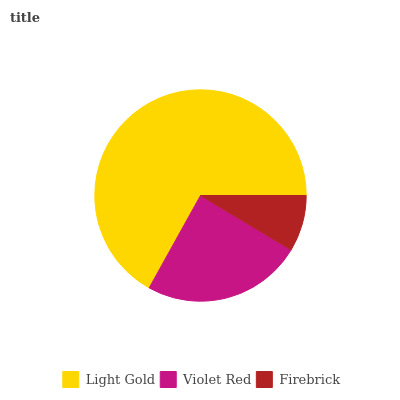Is Firebrick the minimum?
Answer yes or no. Yes. Is Light Gold the maximum?
Answer yes or no. Yes. Is Violet Red the minimum?
Answer yes or no. No. Is Violet Red the maximum?
Answer yes or no. No. Is Light Gold greater than Violet Red?
Answer yes or no. Yes. Is Violet Red less than Light Gold?
Answer yes or no. Yes. Is Violet Red greater than Light Gold?
Answer yes or no. No. Is Light Gold less than Violet Red?
Answer yes or no. No. Is Violet Red the high median?
Answer yes or no. Yes. Is Violet Red the low median?
Answer yes or no. Yes. Is Firebrick the high median?
Answer yes or no. No. Is Firebrick the low median?
Answer yes or no. No. 